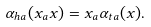<formula> <loc_0><loc_0><loc_500><loc_500>\alpha _ { h a } ( x _ { a } x ) = x _ { a } \alpha _ { t a } ( x ) .</formula> 